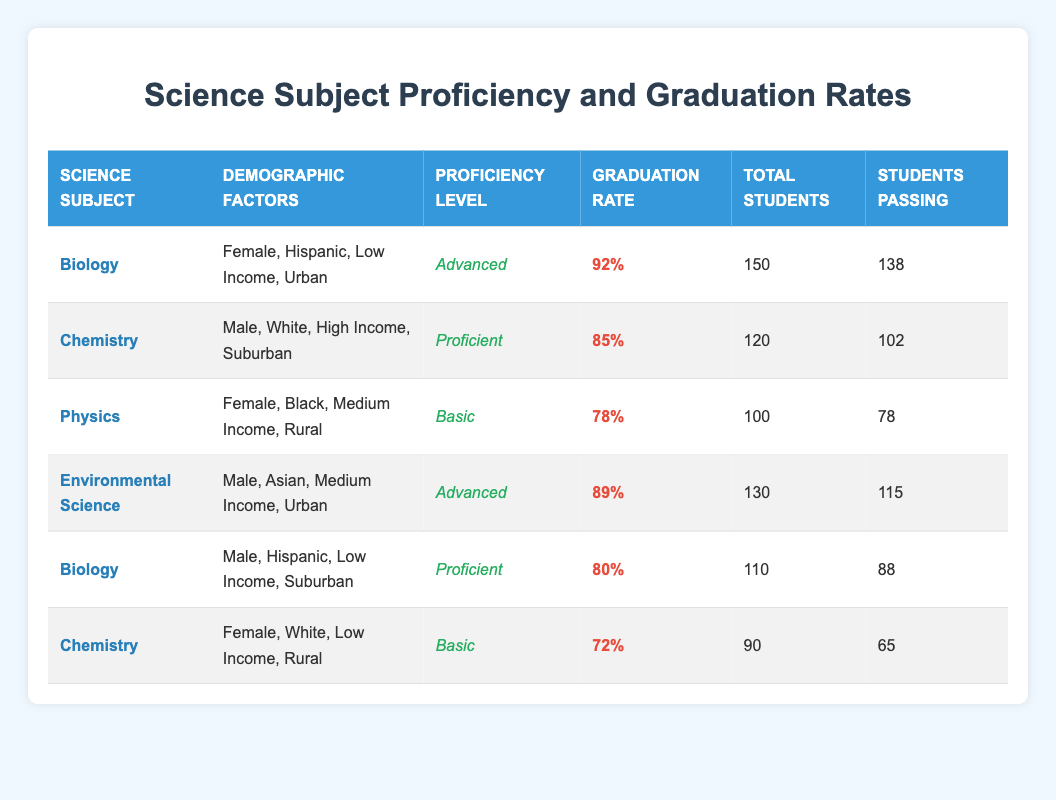What is the graduation rate for Advanced proficiency level in Biology among Hispanic females from low-income urban backgrounds? The table shows that for Biology, the graduation rate for students with Advanced proficiency level, who are Female, Hispanic, from Low Income, and Urban is 92%.
Answer: 92% How many total students are there in the Chemistry category? In the table, there are two entries for Chemistry. One indicates a total of 120 students and the other indicates a total of 90 students. Adding them together gives 120 + 90 = 210.
Answer: 210 Is the graduation rate for female students in Chemistry higher than that of male students in Biology? The graduation rate for female students in Chemistry is 85%, while the rate for male students in Biology is 80%. Since 85% > 80%, the statement is true.
Answer: Yes What is the average graduation rate for the Proficient level across the different subjects? There are two subjects with Proficient levels: Chemistry (85%) and Biology (80%). To find the average, sum the graduation rates: 85 + 80 = 165, and divide by 2, which gives 165 / 2 = 82.5.
Answer: 82.5% How many students passed in Environmental Science? The table states that in Environmental Science, there were 130 total students, and 115 students passed. Directly referring to the data, the number of students passing is given as 115.
Answer: 115 What combination of demographic factors corresponds to the lowest graduation rate among the subjects listed? Looking at the table, Chemistry (Basic proficiency) has a graduation rate of 72%, which is the lowest rate compared to other combinations. The demographic factors are Female, White, Low Income, Rural.
Answer: Female, White, Low Income, Rural What is the difference in graduation rates between the two Biology entries? The first Biology entry has a graduation rate of 92% (Female, Hispanic, Low) and the second has 80% (Male, Hispanic, Low). The difference is 92 - 80 = 12%.
Answer: 12% For which demographic factors in Physics was the graduation rate achieved? The table shows that in Physics, the graduation rate of 78% corresponds to Female, Black, Medium Income, Rural demographic factors.
Answer: Female, Black, Medium Income, Rural 